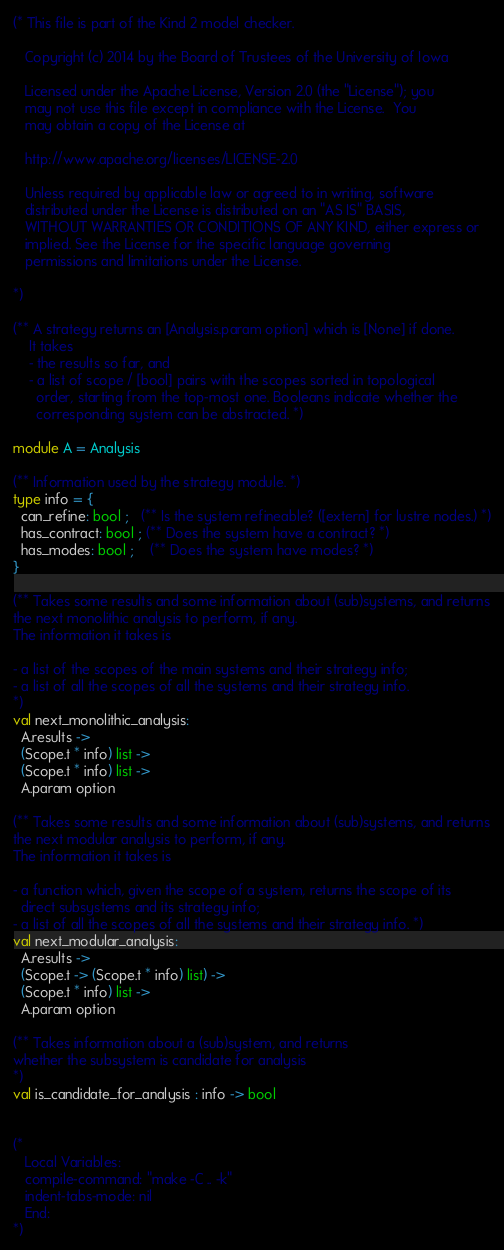<code> <loc_0><loc_0><loc_500><loc_500><_OCaml_>(* This file is part of the Kind 2 model checker.

   Copyright (c) 2014 by the Board of Trustees of the University of Iowa

   Licensed under the Apache License, Version 2.0 (the "License"); you
   may not use this file except in compliance with the License.  You
   may obtain a copy of the License at

   http://www.apache.org/licenses/LICENSE-2.0 

   Unless required by applicable law or agreed to in writing, software
   distributed under the License is distributed on an "AS IS" BASIS,
   WITHOUT WARRANTIES OR CONDITIONS OF ANY KIND, either express or
   implied. See the License for the specific language governing
   permissions and limitations under the License. 

*)

(** A strategy returns an [Analysis.param option] which is [None] if done.
    It takes
    - the results so far, and
    - a list of scope / [bool] pairs with the scopes sorted in topological
      order, starting from the top-most one. Booleans indicate whether the
      corresponding system can be abstracted. *)

module A = Analysis

(** Information used by the strategy module. *)
type info = {
  can_refine: bool ;   (** Is the system refineable? ([extern] for lustre nodes.) *)
  has_contract: bool ; (** Does the system have a contract? *)
  has_modes: bool ;    (** Does the system have modes? *)
}

(** Takes some results and some information about (sub)systems, and returns
the next monolithic analysis to perform, if any.
The information it takes is

- a list of the scopes of the main systems and their strategy info;
- a list of all the scopes of all the systems and their strategy info.
*)
val next_monolithic_analysis:
  A.results ->
  (Scope.t * info) list ->
  (Scope.t * info) list ->
  A.param option

(** Takes some results and some information about (sub)systems, and returns
the next modular analysis to perform, if any.
The information it takes is

- a function which, given the scope of a system, returns the scope of its
  direct subsystems and its strategy info;
- a list of all the scopes of all the systems and their strategy info. *)
val next_modular_analysis:
  A.results ->
  (Scope.t -> (Scope.t * info) list) ->
  (Scope.t * info) list ->
  A.param option

(** Takes information about a (sub)system, and returns
whether the subsystem is candidate for analysis
*)
val is_candidate_for_analysis : info -> bool


(* 
   Local Variables:
   compile-command: "make -C .. -k"
   indent-tabs-mode: nil
   End: 
*)
</code> 